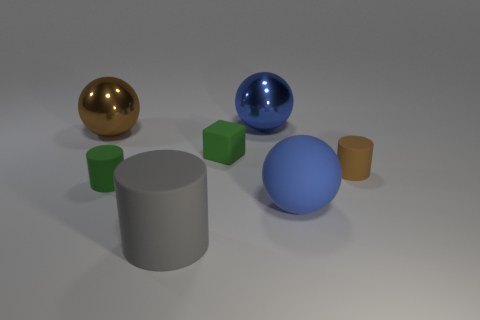There is a blue object that is to the left of the big blue ball that is in front of the big brown sphere; what is its size?
Provide a short and direct response. Large. Are there fewer small matte things that are in front of the tiny brown cylinder than brown rubber cubes?
Provide a succinct answer. No. What is the size of the brown metal sphere?
Offer a very short reply. Large. How many matte things are the same color as the rubber sphere?
Your response must be concise. 0. There is a rubber cylinder that is behind the tiny rubber cylinder that is on the left side of the tiny brown matte object; is there a large matte thing that is behind it?
Your answer should be compact. No. There is another shiny thing that is the same size as the brown metal object; what is its shape?
Your answer should be very brief. Sphere. What number of small objects are either blue rubber balls or shiny objects?
Ensure brevity in your answer.  0. The ball that is the same material as the small brown cylinder is what color?
Give a very brief answer. Blue. There is a small brown rubber object on the right side of the tiny matte block; does it have the same shape as the brown thing that is to the left of the blue shiny ball?
Your answer should be compact. No. How many metal objects are either small green things or tiny green blocks?
Give a very brief answer. 0. 